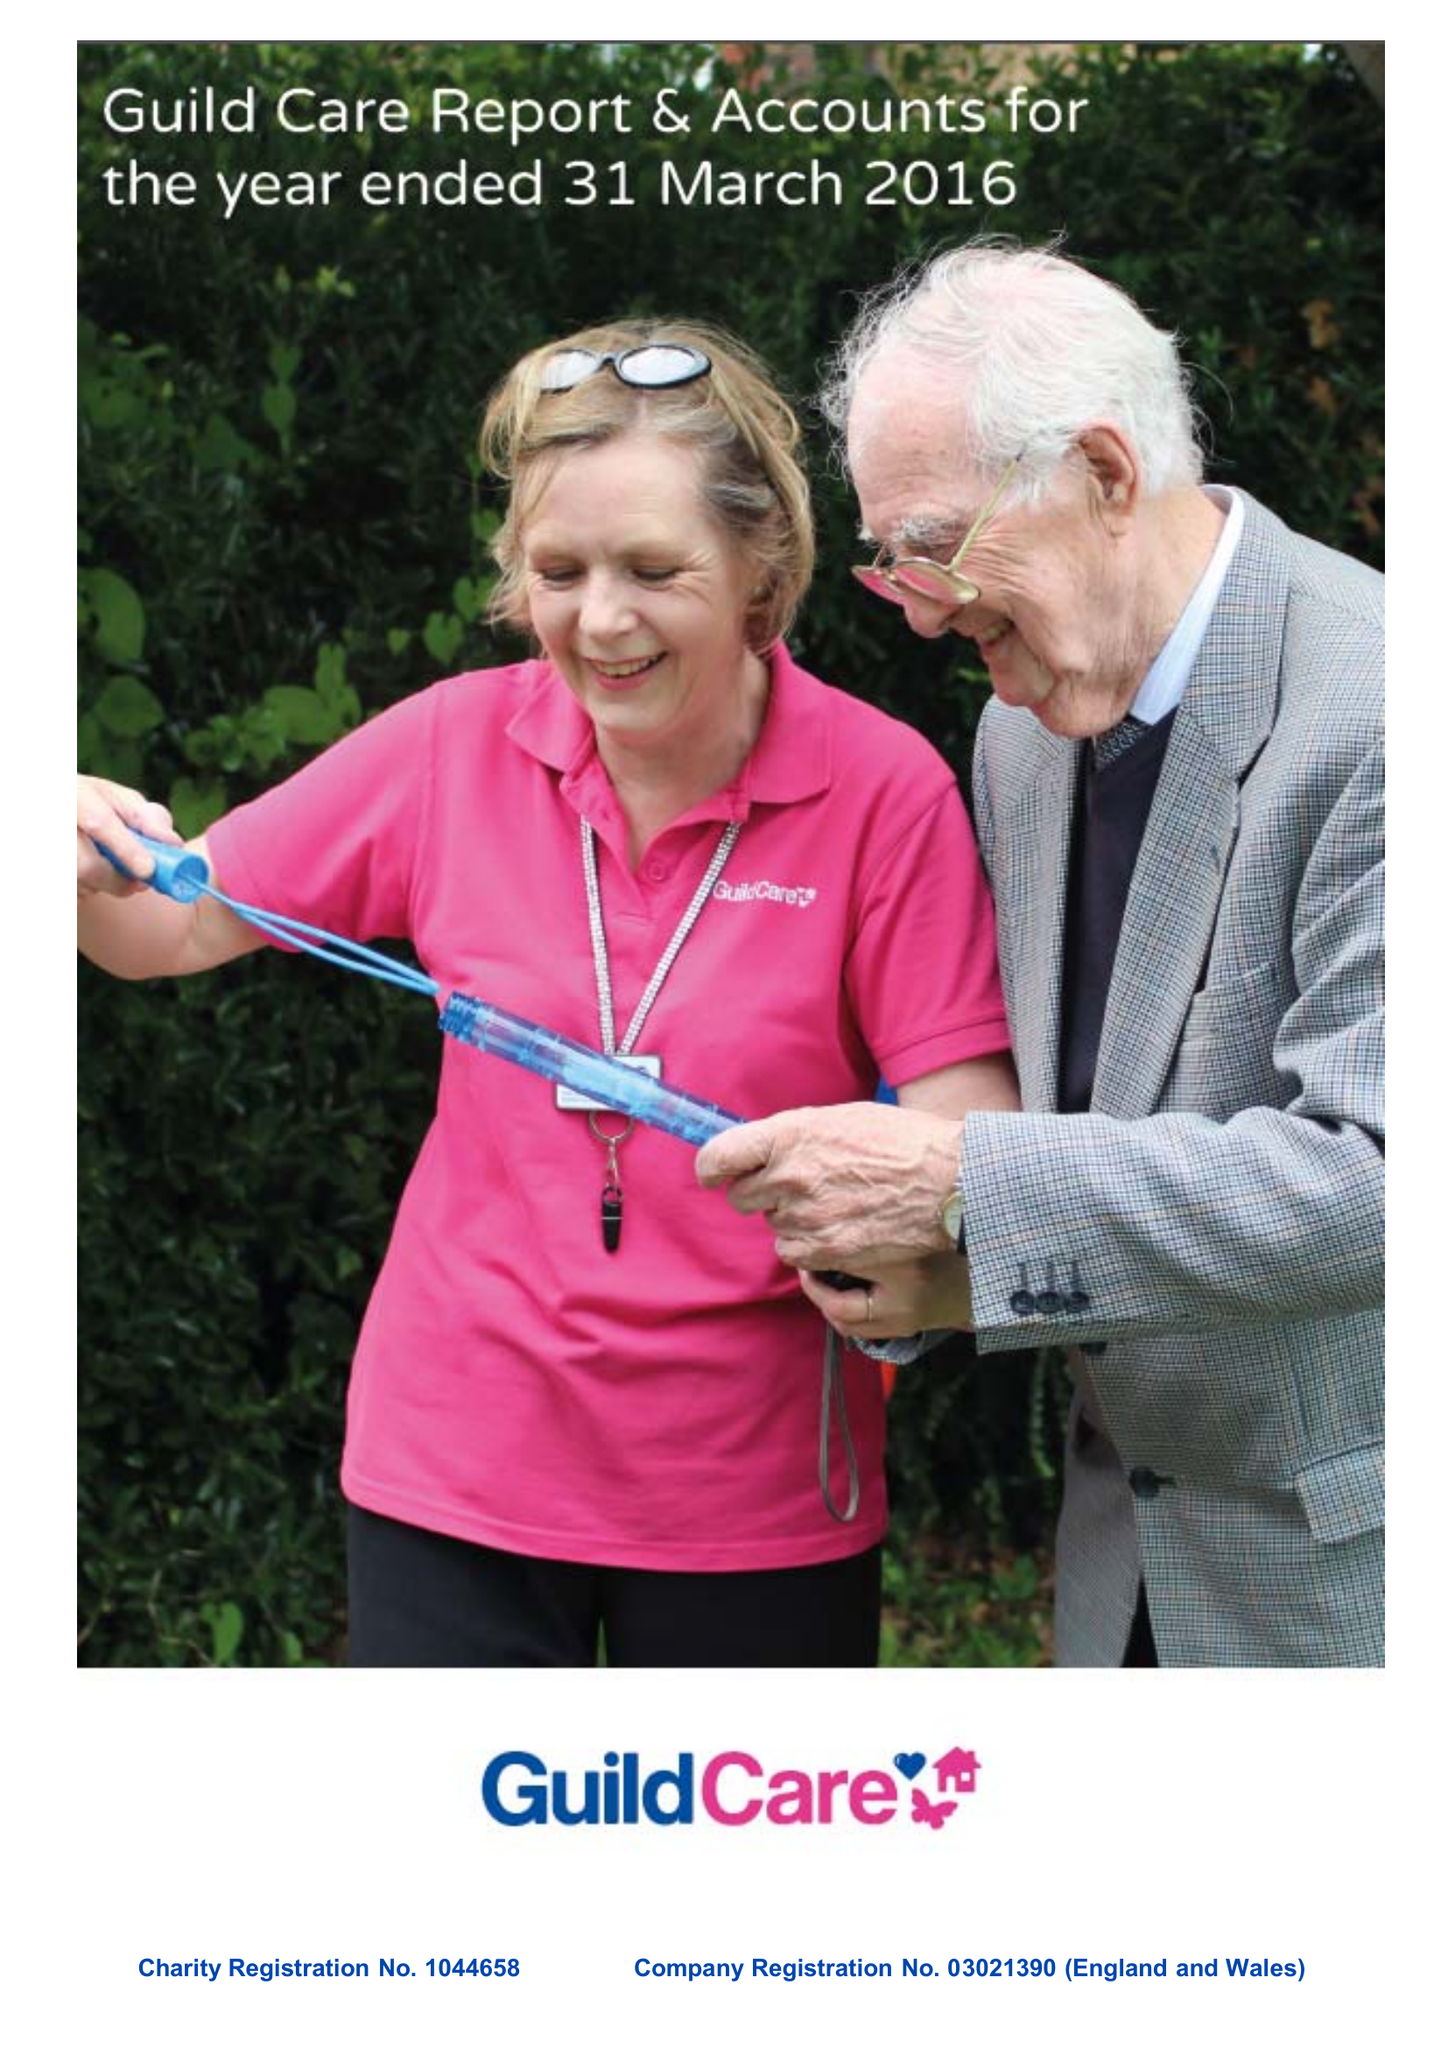What is the value for the income_annually_in_british_pounds?
Answer the question using a single word or phrase. 14129570.00 